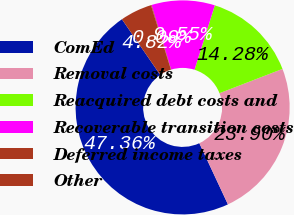Convert chart to OTSL. <chart><loc_0><loc_0><loc_500><loc_500><pie_chart><fcel>ComEd<fcel>Removal costs<fcel>Reacquired debt costs and<fcel>Recoverable transition costs<fcel>Deferred income taxes<fcel>Other<nl><fcel>47.36%<fcel>23.9%<fcel>14.28%<fcel>9.55%<fcel>0.09%<fcel>4.82%<nl></chart> 